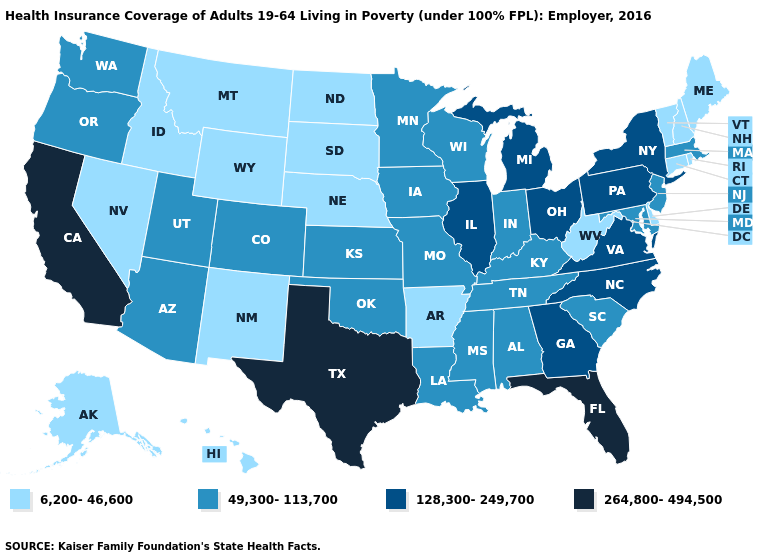Name the states that have a value in the range 6,200-46,600?
Answer briefly. Alaska, Arkansas, Connecticut, Delaware, Hawaii, Idaho, Maine, Montana, Nebraska, Nevada, New Hampshire, New Mexico, North Dakota, Rhode Island, South Dakota, Vermont, West Virginia, Wyoming. Is the legend a continuous bar?
Be succinct. No. Which states have the lowest value in the Northeast?
Quick response, please. Connecticut, Maine, New Hampshire, Rhode Island, Vermont. Does Nevada have the lowest value in the West?
Give a very brief answer. Yes. Name the states that have a value in the range 128,300-249,700?
Be succinct. Georgia, Illinois, Michigan, New York, North Carolina, Ohio, Pennsylvania, Virginia. What is the value of New Hampshire?
Quick response, please. 6,200-46,600. Name the states that have a value in the range 6,200-46,600?
Answer briefly. Alaska, Arkansas, Connecticut, Delaware, Hawaii, Idaho, Maine, Montana, Nebraska, Nevada, New Hampshire, New Mexico, North Dakota, Rhode Island, South Dakota, Vermont, West Virginia, Wyoming. What is the value of Oregon?
Keep it brief. 49,300-113,700. Does the first symbol in the legend represent the smallest category?
Quick response, please. Yes. What is the value of South Dakota?
Be succinct. 6,200-46,600. Is the legend a continuous bar?
Quick response, please. No. Name the states that have a value in the range 49,300-113,700?
Answer briefly. Alabama, Arizona, Colorado, Indiana, Iowa, Kansas, Kentucky, Louisiana, Maryland, Massachusetts, Minnesota, Mississippi, Missouri, New Jersey, Oklahoma, Oregon, South Carolina, Tennessee, Utah, Washington, Wisconsin. Among the states that border Maryland , does Delaware have the highest value?
Quick response, please. No. What is the highest value in states that border Arkansas?
Answer briefly. 264,800-494,500. 